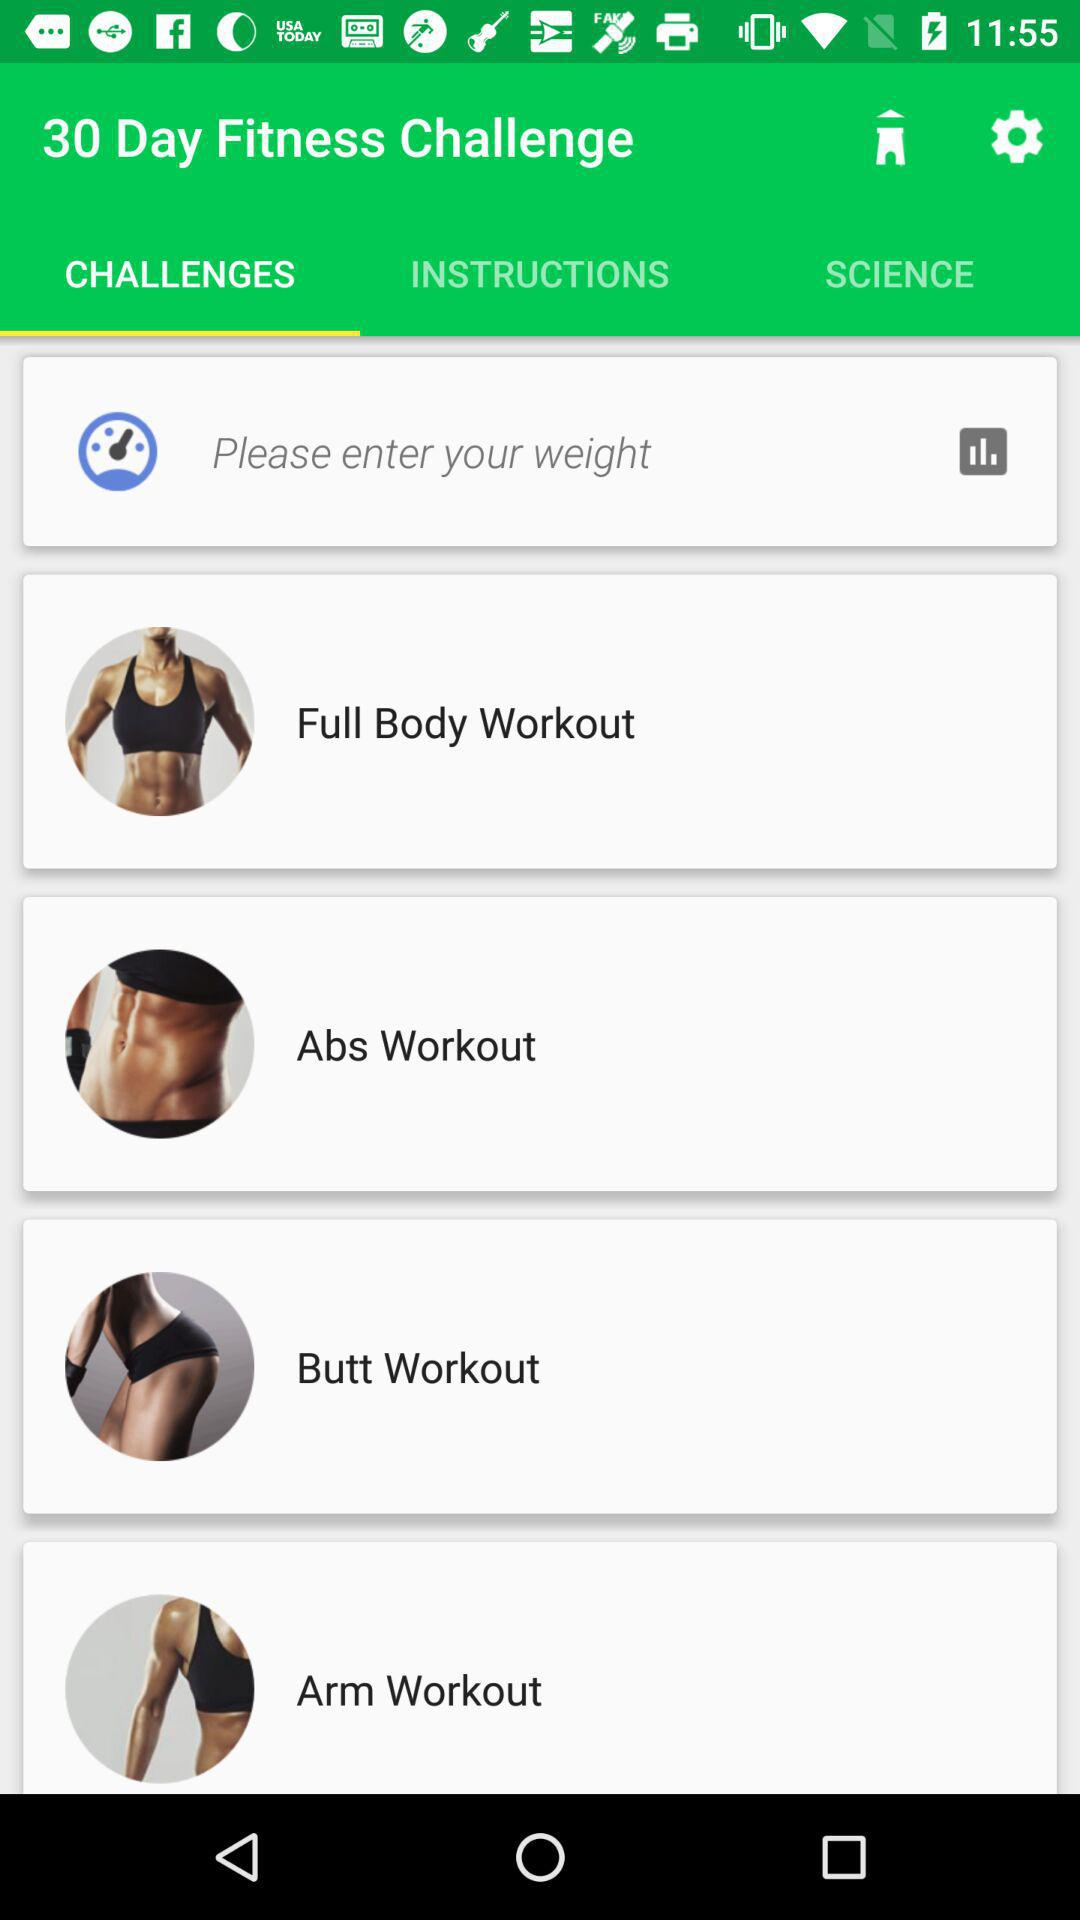How many workouts are there in total?
Answer the question using a single word or phrase. 4 